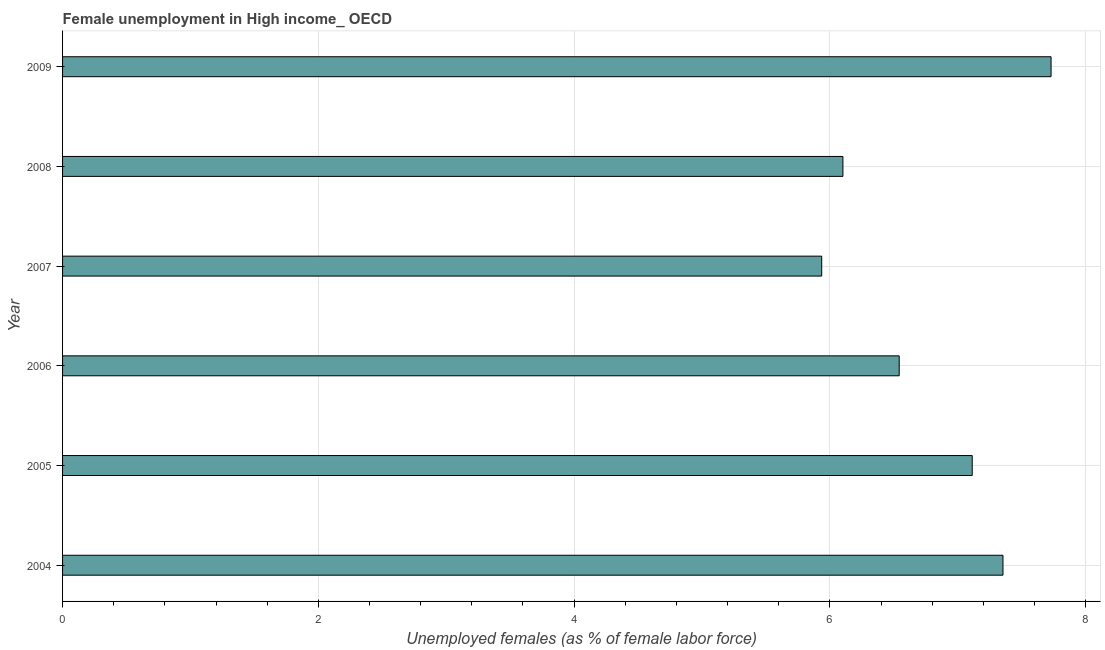Does the graph contain any zero values?
Offer a very short reply. No. Does the graph contain grids?
Keep it short and to the point. Yes. What is the title of the graph?
Provide a succinct answer. Female unemployment in High income_ OECD. What is the label or title of the X-axis?
Provide a short and direct response. Unemployed females (as % of female labor force). What is the unemployed females population in 2009?
Provide a succinct answer. 7.73. Across all years, what is the maximum unemployed females population?
Your answer should be compact. 7.73. Across all years, what is the minimum unemployed females population?
Your answer should be compact. 5.94. In which year was the unemployed females population maximum?
Offer a terse response. 2009. What is the sum of the unemployed females population?
Offer a very short reply. 40.77. What is the difference between the unemployed females population in 2004 and 2007?
Give a very brief answer. 1.42. What is the average unemployed females population per year?
Offer a very short reply. 6.8. What is the median unemployed females population?
Keep it short and to the point. 6.83. In how many years, is the unemployed females population greater than 6.8 %?
Offer a very short reply. 3. What is the ratio of the unemployed females population in 2004 to that in 2005?
Your answer should be very brief. 1.03. Is the unemployed females population in 2005 less than that in 2008?
Offer a very short reply. No. What is the difference between the highest and the second highest unemployed females population?
Keep it short and to the point. 0.38. Is the sum of the unemployed females population in 2004 and 2008 greater than the maximum unemployed females population across all years?
Provide a short and direct response. Yes. What is the difference between the highest and the lowest unemployed females population?
Provide a succinct answer. 1.79. In how many years, is the unemployed females population greater than the average unemployed females population taken over all years?
Your answer should be very brief. 3. Are all the bars in the graph horizontal?
Offer a terse response. Yes. How many years are there in the graph?
Your answer should be compact. 6. What is the difference between two consecutive major ticks on the X-axis?
Your response must be concise. 2. Are the values on the major ticks of X-axis written in scientific E-notation?
Ensure brevity in your answer.  No. What is the Unemployed females (as % of female labor force) in 2004?
Ensure brevity in your answer.  7.35. What is the Unemployed females (as % of female labor force) of 2005?
Offer a very short reply. 7.11. What is the Unemployed females (as % of female labor force) in 2006?
Ensure brevity in your answer.  6.54. What is the Unemployed females (as % of female labor force) of 2007?
Keep it short and to the point. 5.94. What is the Unemployed females (as % of female labor force) in 2008?
Your answer should be compact. 6.1. What is the Unemployed females (as % of female labor force) in 2009?
Your answer should be very brief. 7.73. What is the difference between the Unemployed females (as % of female labor force) in 2004 and 2005?
Provide a short and direct response. 0.24. What is the difference between the Unemployed females (as % of female labor force) in 2004 and 2006?
Keep it short and to the point. 0.81. What is the difference between the Unemployed females (as % of female labor force) in 2004 and 2007?
Offer a terse response. 1.42. What is the difference between the Unemployed females (as % of female labor force) in 2004 and 2008?
Offer a terse response. 1.25. What is the difference between the Unemployed females (as % of female labor force) in 2004 and 2009?
Give a very brief answer. -0.38. What is the difference between the Unemployed females (as % of female labor force) in 2005 and 2006?
Make the answer very short. 0.57. What is the difference between the Unemployed females (as % of female labor force) in 2005 and 2007?
Ensure brevity in your answer.  1.18. What is the difference between the Unemployed females (as % of female labor force) in 2005 and 2008?
Offer a terse response. 1.01. What is the difference between the Unemployed females (as % of female labor force) in 2005 and 2009?
Make the answer very short. -0.62. What is the difference between the Unemployed females (as % of female labor force) in 2006 and 2007?
Offer a terse response. 0.61. What is the difference between the Unemployed females (as % of female labor force) in 2006 and 2008?
Provide a short and direct response. 0.44. What is the difference between the Unemployed females (as % of female labor force) in 2006 and 2009?
Offer a terse response. -1.19. What is the difference between the Unemployed females (as % of female labor force) in 2007 and 2008?
Keep it short and to the point. -0.17. What is the difference between the Unemployed females (as % of female labor force) in 2007 and 2009?
Provide a succinct answer. -1.79. What is the difference between the Unemployed females (as % of female labor force) in 2008 and 2009?
Provide a succinct answer. -1.63. What is the ratio of the Unemployed females (as % of female labor force) in 2004 to that in 2005?
Offer a terse response. 1.03. What is the ratio of the Unemployed females (as % of female labor force) in 2004 to that in 2006?
Offer a terse response. 1.12. What is the ratio of the Unemployed females (as % of female labor force) in 2004 to that in 2007?
Keep it short and to the point. 1.24. What is the ratio of the Unemployed females (as % of female labor force) in 2004 to that in 2008?
Offer a very short reply. 1.21. What is the ratio of the Unemployed females (as % of female labor force) in 2004 to that in 2009?
Your response must be concise. 0.95. What is the ratio of the Unemployed females (as % of female labor force) in 2005 to that in 2006?
Provide a short and direct response. 1.09. What is the ratio of the Unemployed females (as % of female labor force) in 2005 to that in 2007?
Your answer should be compact. 1.2. What is the ratio of the Unemployed females (as % of female labor force) in 2005 to that in 2008?
Your response must be concise. 1.17. What is the ratio of the Unemployed females (as % of female labor force) in 2005 to that in 2009?
Your response must be concise. 0.92. What is the ratio of the Unemployed females (as % of female labor force) in 2006 to that in 2007?
Your answer should be compact. 1.1. What is the ratio of the Unemployed females (as % of female labor force) in 2006 to that in 2008?
Offer a very short reply. 1.07. What is the ratio of the Unemployed females (as % of female labor force) in 2006 to that in 2009?
Ensure brevity in your answer.  0.85. What is the ratio of the Unemployed females (as % of female labor force) in 2007 to that in 2009?
Ensure brevity in your answer.  0.77. What is the ratio of the Unemployed females (as % of female labor force) in 2008 to that in 2009?
Keep it short and to the point. 0.79. 